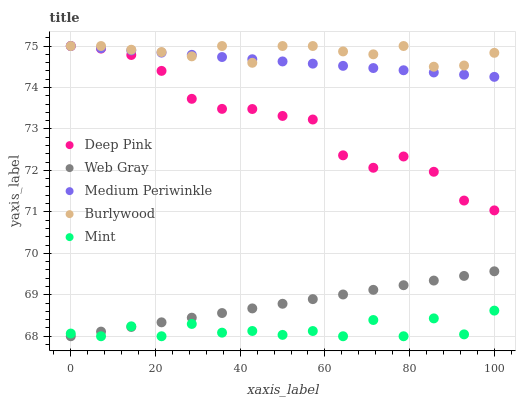Does Mint have the minimum area under the curve?
Answer yes or no. Yes. Does Burlywood have the maximum area under the curve?
Answer yes or no. Yes. Does Medium Periwinkle have the minimum area under the curve?
Answer yes or no. No. Does Medium Periwinkle have the maximum area under the curve?
Answer yes or no. No. Is Medium Periwinkle the smoothest?
Answer yes or no. Yes. Is Mint the roughest?
Answer yes or no. Yes. Is Deep Pink the smoothest?
Answer yes or no. No. Is Deep Pink the roughest?
Answer yes or no. No. Does Web Gray have the lowest value?
Answer yes or no. Yes. Does Medium Periwinkle have the lowest value?
Answer yes or no. No. Does Deep Pink have the highest value?
Answer yes or no. Yes. Does Web Gray have the highest value?
Answer yes or no. No. Is Mint less than Burlywood?
Answer yes or no. Yes. Is Deep Pink greater than Web Gray?
Answer yes or no. Yes. Does Deep Pink intersect Medium Periwinkle?
Answer yes or no. Yes. Is Deep Pink less than Medium Periwinkle?
Answer yes or no. No. Is Deep Pink greater than Medium Periwinkle?
Answer yes or no. No. Does Mint intersect Burlywood?
Answer yes or no. No. 